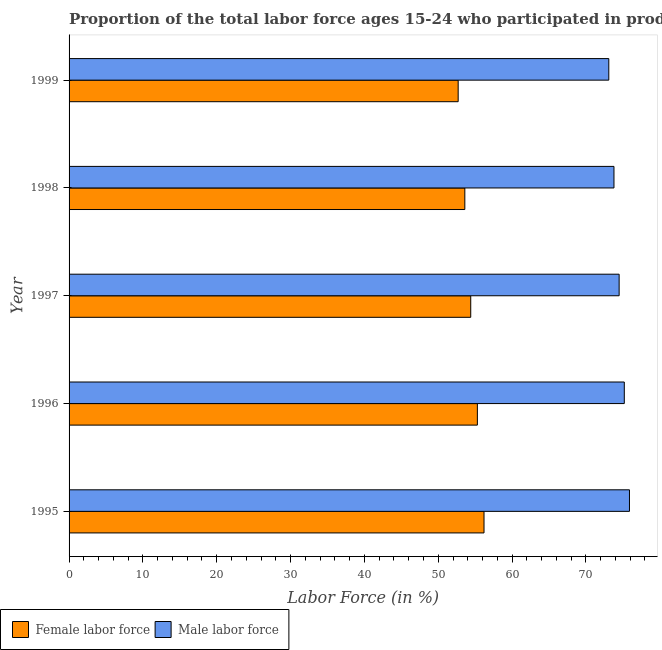How many groups of bars are there?
Provide a short and direct response. 5. Are the number of bars per tick equal to the number of legend labels?
Offer a terse response. Yes. What is the label of the 3rd group of bars from the top?
Provide a short and direct response. 1997. In how many cases, is the number of bars for a given year not equal to the number of legend labels?
Give a very brief answer. 0. What is the percentage of female labor force in 1997?
Your answer should be compact. 54.4. Across all years, what is the maximum percentage of female labor force?
Provide a succinct answer. 56.2. Across all years, what is the minimum percentage of female labor force?
Offer a terse response. 52.7. In which year was the percentage of male labour force maximum?
Your answer should be very brief. 1995. What is the total percentage of male labour force in the graph?
Provide a succinct answer. 372.5. What is the difference between the percentage of male labour force in 1995 and that in 1998?
Offer a terse response. 2.1. What is the difference between the percentage of female labor force in 1996 and the percentage of male labour force in 1999?
Your answer should be compact. -17.8. What is the average percentage of female labor force per year?
Keep it short and to the point. 54.44. What is the ratio of the percentage of female labor force in 1997 to that in 1998?
Your answer should be very brief. 1.01. Is the percentage of male labour force in 1996 less than that in 1998?
Offer a terse response. No. Is the difference between the percentage of male labour force in 1995 and 1996 greater than the difference between the percentage of female labor force in 1995 and 1996?
Your response must be concise. No. What is the difference between the highest and the second highest percentage of female labor force?
Keep it short and to the point. 0.9. In how many years, is the percentage of male labour force greater than the average percentage of male labour force taken over all years?
Your answer should be compact. 3. What does the 1st bar from the top in 1995 represents?
Your answer should be very brief. Male labor force. What does the 1st bar from the bottom in 1999 represents?
Make the answer very short. Female labor force. How many bars are there?
Give a very brief answer. 10. Are all the bars in the graph horizontal?
Your response must be concise. Yes. How many years are there in the graph?
Provide a short and direct response. 5. Are the values on the major ticks of X-axis written in scientific E-notation?
Offer a terse response. No. Does the graph contain any zero values?
Provide a short and direct response. No. Does the graph contain grids?
Your response must be concise. No. How many legend labels are there?
Keep it short and to the point. 2. How are the legend labels stacked?
Offer a terse response. Horizontal. What is the title of the graph?
Your answer should be very brief. Proportion of the total labor force ages 15-24 who participated in production in Bangladesh. What is the label or title of the Y-axis?
Ensure brevity in your answer.  Year. What is the Labor Force (in %) in Female labor force in 1995?
Your answer should be compact. 56.2. What is the Labor Force (in %) of Male labor force in 1995?
Give a very brief answer. 75.9. What is the Labor Force (in %) of Female labor force in 1996?
Your answer should be very brief. 55.3. What is the Labor Force (in %) in Male labor force in 1996?
Keep it short and to the point. 75.2. What is the Labor Force (in %) of Female labor force in 1997?
Keep it short and to the point. 54.4. What is the Labor Force (in %) in Male labor force in 1997?
Offer a terse response. 74.5. What is the Labor Force (in %) in Female labor force in 1998?
Give a very brief answer. 53.6. What is the Labor Force (in %) in Male labor force in 1998?
Make the answer very short. 73.8. What is the Labor Force (in %) in Female labor force in 1999?
Keep it short and to the point. 52.7. What is the Labor Force (in %) of Male labor force in 1999?
Ensure brevity in your answer.  73.1. Across all years, what is the maximum Labor Force (in %) of Female labor force?
Make the answer very short. 56.2. Across all years, what is the maximum Labor Force (in %) of Male labor force?
Keep it short and to the point. 75.9. Across all years, what is the minimum Labor Force (in %) in Female labor force?
Your answer should be very brief. 52.7. Across all years, what is the minimum Labor Force (in %) in Male labor force?
Provide a short and direct response. 73.1. What is the total Labor Force (in %) in Female labor force in the graph?
Give a very brief answer. 272.2. What is the total Labor Force (in %) in Male labor force in the graph?
Ensure brevity in your answer.  372.5. What is the difference between the Labor Force (in %) in Female labor force in 1995 and that in 1996?
Keep it short and to the point. 0.9. What is the difference between the Labor Force (in %) of Male labor force in 1995 and that in 1996?
Your answer should be very brief. 0.7. What is the difference between the Labor Force (in %) in Female labor force in 1995 and that in 1998?
Give a very brief answer. 2.6. What is the difference between the Labor Force (in %) of Male labor force in 1995 and that in 1998?
Your response must be concise. 2.1. What is the difference between the Labor Force (in %) in Male labor force in 1995 and that in 1999?
Provide a short and direct response. 2.8. What is the difference between the Labor Force (in %) in Female labor force in 1996 and that in 1997?
Your answer should be compact. 0.9. What is the difference between the Labor Force (in %) in Male labor force in 1996 and that in 1997?
Give a very brief answer. 0.7. What is the difference between the Labor Force (in %) of Female labor force in 1996 and that in 1998?
Make the answer very short. 1.7. What is the difference between the Labor Force (in %) of Male labor force in 1996 and that in 1998?
Provide a short and direct response. 1.4. What is the difference between the Labor Force (in %) in Female labor force in 1996 and that in 1999?
Give a very brief answer. 2.6. What is the difference between the Labor Force (in %) in Male labor force in 1996 and that in 1999?
Provide a succinct answer. 2.1. What is the difference between the Labor Force (in %) of Male labor force in 1997 and that in 1998?
Offer a very short reply. 0.7. What is the difference between the Labor Force (in %) of Female labor force in 1998 and that in 1999?
Offer a terse response. 0.9. What is the difference between the Labor Force (in %) in Male labor force in 1998 and that in 1999?
Provide a succinct answer. 0.7. What is the difference between the Labor Force (in %) of Female labor force in 1995 and the Labor Force (in %) of Male labor force in 1997?
Ensure brevity in your answer.  -18.3. What is the difference between the Labor Force (in %) in Female labor force in 1995 and the Labor Force (in %) in Male labor force in 1998?
Your response must be concise. -17.6. What is the difference between the Labor Force (in %) of Female labor force in 1995 and the Labor Force (in %) of Male labor force in 1999?
Your response must be concise. -16.9. What is the difference between the Labor Force (in %) of Female labor force in 1996 and the Labor Force (in %) of Male labor force in 1997?
Make the answer very short. -19.2. What is the difference between the Labor Force (in %) in Female labor force in 1996 and the Labor Force (in %) in Male labor force in 1998?
Your response must be concise. -18.5. What is the difference between the Labor Force (in %) of Female labor force in 1996 and the Labor Force (in %) of Male labor force in 1999?
Ensure brevity in your answer.  -17.8. What is the difference between the Labor Force (in %) of Female labor force in 1997 and the Labor Force (in %) of Male labor force in 1998?
Make the answer very short. -19.4. What is the difference between the Labor Force (in %) of Female labor force in 1997 and the Labor Force (in %) of Male labor force in 1999?
Provide a succinct answer. -18.7. What is the difference between the Labor Force (in %) in Female labor force in 1998 and the Labor Force (in %) in Male labor force in 1999?
Make the answer very short. -19.5. What is the average Labor Force (in %) of Female labor force per year?
Your answer should be very brief. 54.44. What is the average Labor Force (in %) of Male labor force per year?
Your answer should be very brief. 74.5. In the year 1995, what is the difference between the Labor Force (in %) in Female labor force and Labor Force (in %) in Male labor force?
Your answer should be very brief. -19.7. In the year 1996, what is the difference between the Labor Force (in %) of Female labor force and Labor Force (in %) of Male labor force?
Your answer should be compact. -19.9. In the year 1997, what is the difference between the Labor Force (in %) of Female labor force and Labor Force (in %) of Male labor force?
Offer a very short reply. -20.1. In the year 1998, what is the difference between the Labor Force (in %) in Female labor force and Labor Force (in %) in Male labor force?
Give a very brief answer. -20.2. In the year 1999, what is the difference between the Labor Force (in %) of Female labor force and Labor Force (in %) of Male labor force?
Your answer should be very brief. -20.4. What is the ratio of the Labor Force (in %) of Female labor force in 1995 to that in 1996?
Make the answer very short. 1.02. What is the ratio of the Labor Force (in %) in Male labor force in 1995 to that in 1996?
Ensure brevity in your answer.  1.01. What is the ratio of the Labor Force (in %) of Female labor force in 1995 to that in 1997?
Ensure brevity in your answer.  1.03. What is the ratio of the Labor Force (in %) of Male labor force in 1995 to that in 1997?
Offer a very short reply. 1.02. What is the ratio of the Labor Force (in %) in Female labor force in 1995 to that in 1998?
Make the answer very short. 1.05. What is the ratio of the Labor Force (in %) in Male labor force in 1995 to that in 1998?
Offer a very short reply. 1.03. What is the ratio of the Labor Force (in %) of Female labor force in 1995 to that in 1999?
Offer a very short reply. 1.07. What is the ratio of the Labor Force (in %) in Male labor force in 1995 to that in 1999?
Offer a very short reply. 1.04. What is the ratio of the Labor Force (in %) in Female labor force in 1996 to that in 1997?
Your answer should be very brief. 1.02. What is the ratio of the Labor Force (in %) in Male labor force in 1996 to that in 1997?
Give a very brief answer. 1.01. What is the ratio of the Labor Force (in %) of Female labor force in 1996 to that in 1998?
Provide a short and direct response. 1.03. What is the ratio of the Labor Force (in %) in Male labor force in 1996 to that in 1998?
Your answer should be compact. 1.02. What is the ratio of the Labor Force (in %) in Female labor force in 1996 to that in 1999?
Offer a very short reply. 1.05. What is the ratio of the Labor Force (in %) in Male labor force in 1996 to that in 1999?
Keep it short and to the point. 1.03. What is the ratio of the Labor Force (in %) of Female labor force in 1997 to that in 1998?
Your answer should be compact. 1.01. What is the ratio of the Labor Force (in %) of Male labor force in 1997 to that in 1998?
Your response must be concise. 1.01. What is the ratio of the Labor Force (in %) in Female labor force in 1997 to that in 1999?
Provide a short and direct response. 1.03. What is the ratio of the Labor Force (in %) in Male labor force in 1997 to that in 1999?
Your answer should be very brief. 1.02. What is the ratio of the Labor Force (in %) in Female labor force in 1998 to that in 1999?
Offer a terse response. 1.02. What is the ratio of the Labor Force (in %) in Male labor force in 1998 to that in 1999?
Your answer should be very brief. 1.01. What is the difference between the highest and the second highest Labor Force (in %) in Male labor force?
Give a very brief answer. 0.7. What is the difference between the highest and the lowest Labor Force (in %) in Female labor force?
Give a very brief answer. 3.5. What is the difference between the highest and the lowest Labor Force (in %) in Male labor force?
Your answer should be very brief. 2.8. 